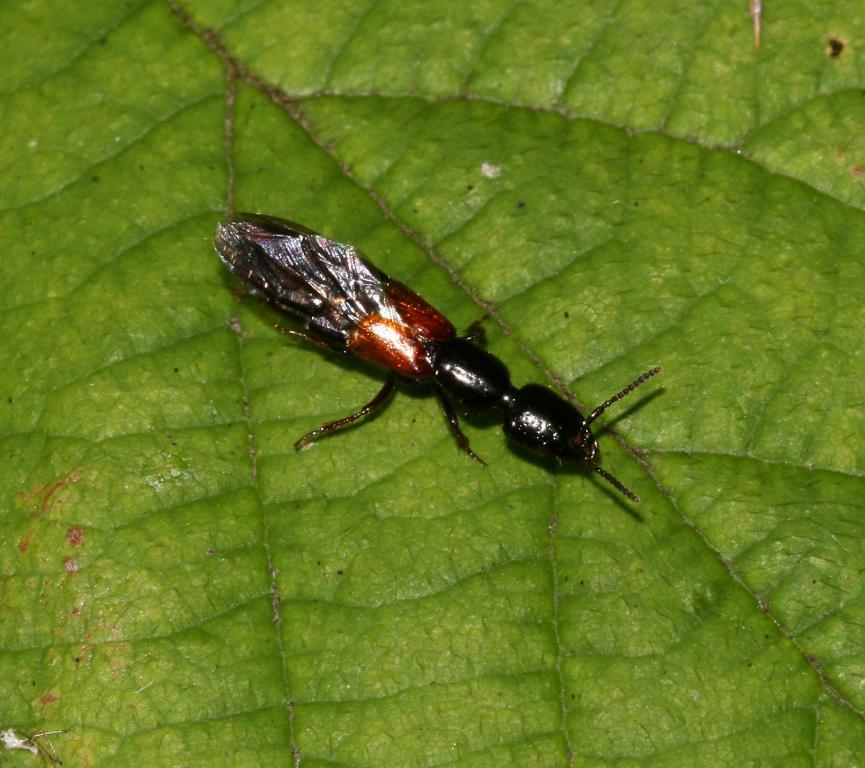What type of creature can be seen in the image? There is an insect present in the image. Where is the insect located in the image? The insect is on a leaf. What day of the week is it according to the calendar in the image? There is no calendar present in the image. What type of body part can be seen on the insect in the image? The image does not show any specific body part of the insect. 